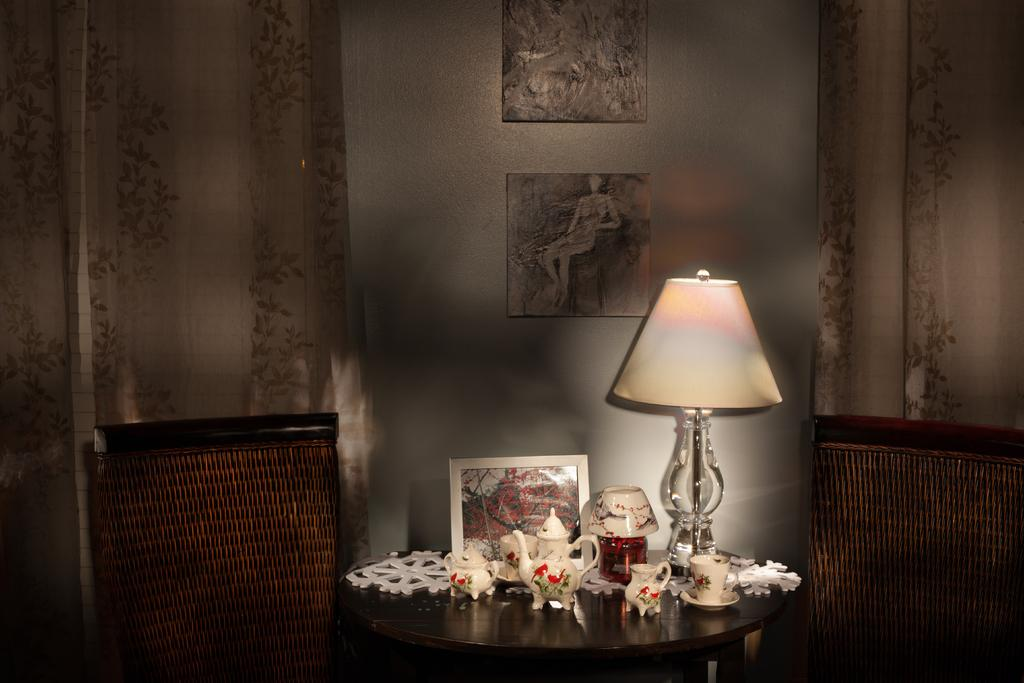What piece of furniture is present in the image? There is a table in the image. What is on top of the table? The table has a lamp and a photo frame on it. Are there any other objects on the table? Yes, there are other objects on the table. What can be seen in the background of the image? There are other objects visible in the background of the image. How does the family interact with the art in the image? There is no family or art present in the image. 